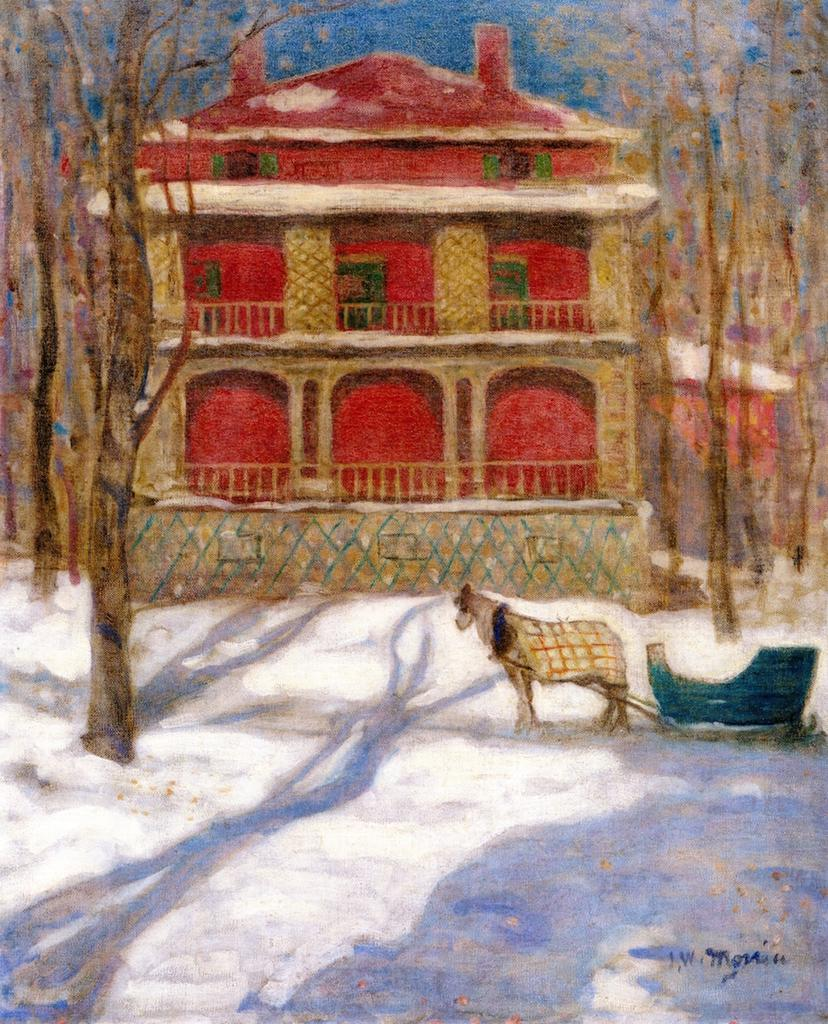What type of structure is present in the image? There is a building in the image. What can be seen on the right side of the image? There is an animal standing on the right side of the image. What is the ground covered with in the image? There is snow at the bottom of the image. What type of vegetation is visible in the image? There are trees visible in the image. What type of kitty is using a quill to gain knowledge in the image? There is no kitty or quill present in the image. 